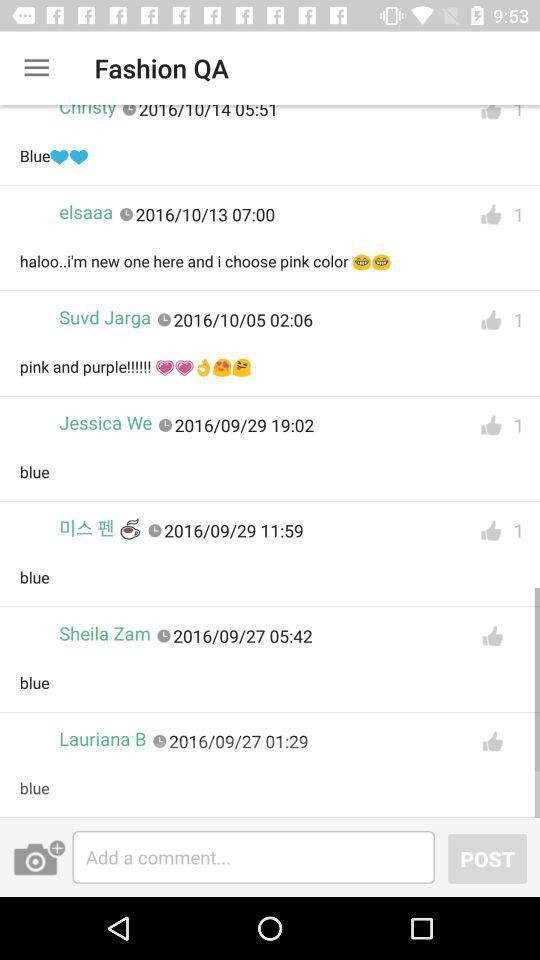How many likes are there for Elsaaa's comment? There is 1 like. 